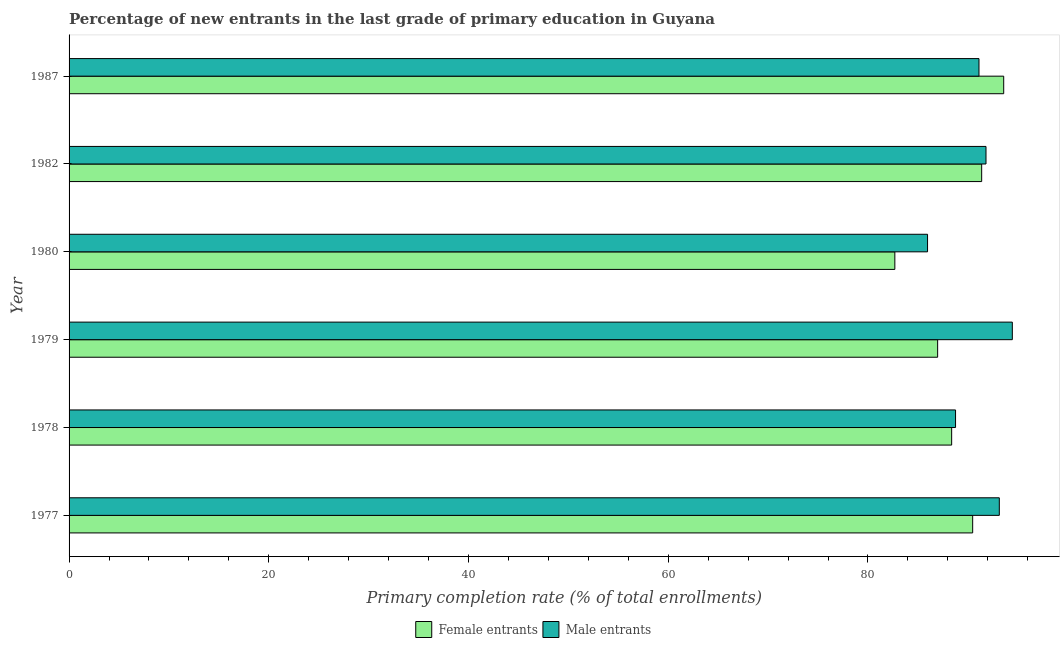How many groups of bars are there?
Offer a terse response. 6. How many bars are there on the 5th tick from the top?
Offer a terse response. 2. What is the primary completion rate of male entrants in 1979?
Your answer should be very brief. 94.45. Across all years, what is the maximum primary completion rate of female entrants?
Your answer should be very brief. 93.59. Across all years, what is the minimum primary completion rate of male entrants?
Give a very brief answer. 85.96. In which year was the primary completion rate of male entrants maximum?
Give a very brief answer. 1979. In which year was the primary completion rate of male entrants minimum?
Make the answer very short. 1980. What is the total primary completion rate of male entrants in the graph?
Offer a very short reply. 545.27. What is the difference between the primary completion rate of male entrants in 1977 and that in 1982?
Give a very brief answer. 1.33. What is the difference between the primary completion rate of female entrants in 1978 and the primary completion rate of male entrants in 1979?
Your response must be concise. -6.08. What is the average primary completion rate of male entrants per year?
Ensure brevity in your answer.  90.88. In the year 1980, what is the difference between the primary completion rate of female entrants and primary completion rate of male entrants?
Your answer should be very brief. -3.27. Is the primary completion rate of female entrants in 1978 less than that in 1987?
Offer a terse response. Yes. Is the difference between the primary completion rate of female entrants in 1980 and 1987 greater than the difference between the primary completion rate of male entrants in 1980 and 1987?
Keep it short and to the point. No. What is the difference between the highest and the second highest primary completion rate of female entrants?
Your answer should be compact. 2.21. What is the difference between the highest and the lowest primary completion rate of male entrants?
Ensure brevity in your answer.  8.49. In how many years, is the primary completion rate of female entrants greater than the average primary completion rate of female entrants taken over all years?
Make the answer very short. 3. What does the 1st bar from the top in 1987 represents?
Ensure brevity in your answer.  Male entrants. What does the 2nd bar from the bottom in 1982 represents?
Make the answer very short. Male entrants. How many bars are there?
Make the answer very short. 12. What is the difference between two consecutive major ticks on the X-axis?
Your answer should be very brief. 20. Are the values on the major ticks of X-axis written in scientific E-notation?
Provide a short and direct response. No. Does the graph contain grids?
Ensure brevity in your answer.  No. Where does the legend appear in the graph?
Give a very brief answer. Bottom center. What is the title of the graph?
Offer a very short reply. Percentage of new entrants in the last grade of primary education in Guyana. Does "Resident workers" appear as one of the legend labels in the graph?
Your response must be concise. No. What is the label or title of the X-axis?
Provide a short and direct response. Primary completion rate (% of total enrollments). What is the label or title of the Y-axis?
Ensure brevity in your answer.  Year. What is the Primary completion rate (% of total enrollments) in Female entrants in 1977?
Offer a terse response. 90.48. What is the Primary completion rate (% of total enrollments) in Male entrants in 1977?
Provide a short and direct response. 93.15. What is the Primary completion rate (% of total enrollments) in Female entrants in 1978?
Ensure brevity in your answer.  88.38. What is the Primary completion rate (% of total enrollments) in Male entrants in 1978?
Offer a terse response. 88.77. What is the Primary completion rate (% of total enrollments) in Female entrants in 1979?
Offer a terse response. 86.98. What is the Primary completion rate (% of total enrollments) of Male entrants in 1979?
Provide a short and direct response. 94.45. What is the Primary completion rate (% of total enrollments) of Female entrants in 1980?
Your answer should be compact. 82.69. What is the Primary completion rate (% of total enrollments) of Male entrants in 1980?
Make the answer very short. 85.96. What is the Primary completion rate (% of total enrollments) in Female entrants in 1982?
Your response must be concise. 91.38. What is the Primary completion rate (% of total enrollments) in Male entrants in 1982?
Offer a terse response. 91.82. What is the Primary completion rate (% of total enrollments) in Female entrants in 1987?
Ensure brevity in your answer.  93.59. What is the Primary completion rate (% of total enrollments) of Male entrants in 1987?
Provide a succinct answer. 91.12. Across all years, what is the maximum Primary completion rate (% of total enrollments) of Female entrants?
Provide a short and direct response. 93.59. Across all years, what is the maximum Primary completion rate (% of total enrollments) of Male entrants?
Provide a short and direct response. 94.45. Across all years, what is the minimum Primary completion rate (% of total enrollments) of Female entrants?
Provide a short and direct response. 82.69. Across all years, what is the minimum Primary completion rate (% of total enrollments) in Male entrants?
Your answer should be compact. 85.96. What is the total Primary completion rate (% of total enrollments) of Female entrants in the graph?
Provide a short and direct response. 533.5. What is the total Primary completion rate (% of total enrollments) of Male entrants in the graph?
Provide a short and direct response. 545.27. What is the difference between the Primary completion rate (% of total enrollments) in Female entrants in 1977 and that in 1978?
Your answer should be very brief. 2.1. What is the difference between the Primary completion rate (% of total enrollments) of Male entrants in 1977 and that in 1978?
Give a very brief answer. 4.38. What is the difference between the Primary completion rate (% of total enrollments) of Female entrants in 1977 and that in 1979?
Provide a succinct answer. 3.51. What is the difference between the Primary completion rate (% of total enrollments) of Male entrants in 1977 and that in 1979?
Provide a short and direct response. -1.3. What is the difference between the Primary completion rate (% of total enrollments) in Female entrants in 1977 and that in 1980?
Your answer should be compact. 7.79. What is the difference between the Primary completion rate (% of total enrollments) in Male entrants in 1977 and that in 1980?
Your answer should be very brief. 7.19. What is the difference between the Primary completion rate (% of total enrollments) of Female entrants in 1977 and that in 1982?
Your response must be concise. -0.9. What is the difference between the Primary completion rate (% of total enrollments) of Male entrants in 1977 and that in 1982?
Offer a terse response. 1.33. What is the difference between the Primary completion rate (% of total enrollments) of Female entrants in 1977 and that in 1987?
Offer a very short reply. -3.11. What is the difference between the Primary completion rate (% of total enrollments) of Male entrants in 1977 and that in 1987?
Your response must be concise. 2.03. What is the difference between the Primary completion rate (% of total enrollments) in Female entrants in 1978 and that in 1979?
Offer a very short reply. 1.4. What is the difference between the Primary completion rate (% of total enrollments) in Male entrants in 1978 and that in 1979?
Offer a very short reply. -5.69. What is the difference between the Primary completion rate (% of total enrollments) of Female entrants in 1978 and that in 1980?
Provide a short and direct response. 5.69. What is the difference between the Primary completion rate (% of total enrollments) in Male entrants in 1978 and that in 1980?
Make the answer very short. 2.8. What is the difference between the Primary completion rate (% of total enrollments) in Female entrants in 1978 and that in 1982?
Ensure brevity in your answer.  -3.01. What is the difference between the Primary completion rate (% of total enrollments) of Male entrants in 1978 and that in 1982?
Your answer should be very brief. -3.05. What is the difference between the Primary completion rate (% of total enrollments) of Female entrants in 1978 and that in 1987?
Provide a succinct answer. -5.21. What is the difference between the Primary completion rate (% of total enrollments) of Male entrants in 1978 and that in 1987?
Offer a terse response. -2.35. What is the difference between the Primary completion rate (% of total enrollments) of Female entrants in 1979 and that in 1980?
Give a very brief answer. 4.29. What is the difference between the Primary completion rate (% of total enrollments) in Male entrants in 1979 and that in 1980?
Provide a succinct answer. 8.49. What is the difference between the Primary completion rate (% of total enrollments) of Female entrants in 1979 and that in 1982?
Provide a short and direct response. -4.41. What is the difference between the Primary completion rate (% of total enrollments) in Male entrants in 1979 and that in 1982?
Make the answer very short. 2.64. What is the difference between the Primary completion rate (% of total enrollments) in Female entrants in 1979 and that in 1987?
Offer a terse response. -6.61. What is the difference between the Primary completion rate (% of total enrollments) in Male entrants in 1979 and that in 1987?
Offer a terse response. 3.34. What is the difference between the Primary completion rate (% of total enrollments) in Female entrants in 1980 and that in 1982?
Your response must be concise. -8.69. What is the difference between the Primary completion rate (% of total enrollments) of Male entrants in 1980 and that in 1982?
Make the answer very short. -5.85. What is the difference between the Primary completion rate (% of total enrollments) of Female entrants in 1980 and that in 1987?
Give a very brief answer. -10.9. What is the difference between the Primary completion rate (% of total enrollments) in Male entrants in 1980 and that in 1987?
Your response must be concise. -5.15. What is the difference between the Primary completion rate (% of total enrollments) of Female entrants in 1982 and that in 1987?
Keep it short and to the point. -2.21. What is the difference between the Primary completion rate (% of total enrollments) of Male entrants in 1982 and that in 1987?
Offer a terse response. 0.7. What is the difference between the Primary completion rate (% of total enrollments) of Female entrants in 1977 and the Primary completion rate (% of total enrollments) of Male entrants in 1978?
Your answer should be compact. 1.72. What is the difference between the Primary completion rate (% of total enrollments) of Female entrants in 1977 and the Primary completion rate (% of total enrollments) of Male entrants in 1979?
Provide a short and direct response. -3.97. What is the difference between the Primary completion rate (% of total enrollments) in Female entrants in 1977 and the Primary completion rate (% of total enrollments) in Male entrants in 1980?
Your response must be concise. 4.52. What is the difference between the Primary completion rate (% of total enrollments) of Female entrants in 1977 and the Primary completion rate (% of total enrollments) of Male entrants in 1982?
Make the answer very short. -1.33. What is the difference between the Primary completion rate (% of total enrollments) in Female entrants in 1977 and the Primary completion rate (% of total enrollments) in Male entrants in 1987?
Your answer should be very brief. -0.63. What is the difference between the Primary completion rate (% of total enrollments) of Female entrants in 1978 and the Primary completion rate (% of total enrollments) of Male entrants in 1979?
Your response must be concise. -6.08. What is the difference between the Primary completion rate (% of total enrollments) in Female entrants in 1978 and the Primary completion rate (% of total enrollments) in Male entrants in 1980?
Offer a very short reply. 2.41. What is the difference between the Primary completion rate (% of total enrollments) of Female entrants in 1978 and the Primary completion rate (% of total enrollments) of Male entrants in 1982?
Give a very brief answer. -3.44. What is the difference between the Primary completion rate (% of total enrollments) in Female entrants in 1978 and the Primary completion rate (% of total enrollments) in Male entrants in 1987?
Keep it short and to the point. -2.74. What is the difference between the Primary completion rate (% of total enrollments) in Female entrants in 1979 and the Primary completion rate (% of total enrollments) in Male entrants in 1980?
Your answer should be compact. 1.01. What is the difference between the Primary completion rate (% of total enrollments) of Female entrants in 1979 and the Primary completion rate (% of total enrollments) of Male entrants in 1982?
Ensure brevity in your answer.  -4.84. What is the difference between the Primary completion rate (% of total enrollments) in Female entrants in 1979 and the Primary completion rate (% of total enrollments) in Male entrants in 1987?
Keep it short and to the point. -4.14. What is the difference between the Primary completion rate (% of total enrollments) of Female entrants in 1980 and the Primary completion rate (% of total enrollments) of Male entrants in 1982?
Offer a very short reply. -9.13. What is the difference between the Primary completion rate (% of total enrollments) of Female entrants in 1980 and the Primary completion rate (% of total enrollments) of Male entrants in 1987?
Your answer should be very brief. -8.43. What is the difference between the Primary completion rate (% of total enrollments) in Female entrants in 1982 and the Primary completion rate (% of total enrollments) in Male entrants in 1987?
Make the answer very short. 0.27. What is the average Primary completion rate (% of total enrollments) in Female entrants per year?
Make the answer very short. 88.92. What is the average Primary completion rate (% of total enrollments) in Male entrants per year?
Your answer should be very brief. 90.88. In the year 1977, what is the difference between the Primary completion rate (% of total enrollments) in Female entrants and Primary completion rate (% of total enrollments) in Male entrants?
Provide a short and direct response. -2.67. In the year 1978, what is the difference between the Primary completion rate (% of total enrollments) in Female entrants and Primary completion rate (% of total enrollments) in Male entrants?
Provide a succinct answer. -0.39. In the year 1979, what is the difference between the Primary completion rate (% of total enrollments) of Female entrants and Primary completion rate (% of total enrollments) of Male entrants?
Your response must be concise. -7.48. In the year 1980, what is the difference between the Primary completion rate (% of total enrollments) of Female entrants and Primary completion rate (% of total enrollments) of Male entrants?
Ensure brevity in your answer.  -3.27. In the year 1982, what is the difference between the Primary completion rate (% of total enrollments) of Female entrants and Primary completion rate (% of total enrollments) of Male entrants?
Your answer should be very brief. -0.43. In the year 1987, what is the difference between the Primary completion rate (% of total enrollments) of Female entrants and Primary completion rate (% of total enrollments) of Male entrants?
Your answer should be very brief. 2.47. What is the ratio of the Primary completion rate (% of total enrollments) in Female entrants in 1977 to that in 1978?
Give a very brief answer. 1.02. What is the ratio of the Primary completion rate (% of total enrollments) of Male entrants in 1977 to that in 1978?
Offer a very short reply. 1.05. What is the ratio of the Primary completion rate (% of total enrollments) of Female entrants in 1977 to that in 1979?
Your answer should be very brief. 1.04. What is the ratio of the Primary completion rate (% of total enrollments) in Male entrants in 1977 to that in 1979?
Offer a terse response. 0.99. What is the ratio of the Primary completion rate (% of total enrollments) in Female entrants in 1977 to that in 1980?
Provide a short and direct response. 1.09. What is the ratio of the Primary completion rate (% of total enrollments) in Male entrants in 1977 to that in 1980?
Your answer should be compact. 1.08. What is the ratio of the Primary completion rate (% of total enrollments) in Male entrants in 1977 to that in 1982?
Ensure brevity in your answer.  1.01. What is the ratio of the Primary completion rate (% of total enrollments) of Female entrants in 1977 to that in 1987?
Your answer should be very brief. 0.97. What is the ratio of the Primary completion rate (% of total enrollments) in Male entrants in 1977 to that in 1987?
Your response must be concise. 1.02. What is the ratio of the Primary completion rate (% of total enrollments) of Female entrants in 1978 to that in 1979?
Give a very brief answer. 1.02. What is the ratio of the Primary completion rate (% of total enrollments) of Male entrants in 1978 to that in 1979?
Provide a succinct answer. 0.94. What is the ratio of the Primary completion rate (% of total enrollments) in Female entrants in 1978 to that in 1980?
Provide a short and direct response. 1.07. What is the ratio of the Primary completion rate (% of total enrollments) of Male entrants in 1978 to that in 1980?
Offer a very short reply. 1.03. What is the ratio of the Primary completion rate (% of total enrollments) of Female entrants in 1978 to that in 1982?
Make the answer very short. 0.97. What is the ratio of the Primary completion rate (% of total enrollments) in Male entrants in 1978 to that in 1982?
Offer a terse response. 0.97. What is the ratio of the Primary completion rate (% of total enrollments) of Female entrants in 1978 to that in 1987?
Ensure brevity in your answer.  0.94. What is the ratio of the Primary completion rate (% of total enrollments) of Male entrants in 1978 to that in 1987?
Keep it short and to the point. 0.97. What is the ratio of the Primary completion rate (% of total enrollments) of Female entrants in 1979 to that in 1980?
Your answer should be compact. 1.05. What is the ratio of the Primary completion rate (% of total enrollments) of Male entrants in 1979 to that in 1980?
Keep it short and to the point. 1.1. What is the ratio of the Primary completion rate (% of total enrollments) in Female entrants in 1979 to that in 1982?
Provide a short and direct response. 0.95. What is the ratio of the Primary completion rate (% of total enrollments) in Male entrants in 1979 to that in 1982?
Provide a short and direct response. 1.03. What is the ratio of the Primary completion rate (% of total enrollments) of Female entrants in 1979 to that in 1987?
Provide a succinct answer. 0.93. What is the ratio of the Primary completion rate (% of total enrollments) of Male entrants in 1979 to that in 1987?
Offer a terse response. 1.04. What is the ratio of the Primary completion rate (% of total enrollments) of Female entrants in 1980 to that in 1982?
Your response must be concise. 0.9. What is the ratio of the Primary completion rate (% of total enrollments) in Male entrants in 1980 to that in 1982?
Give a very brief answer. 0.94. What is the ratio of the Primary completion rate (% of total enrollments) of Female entrants in 1980 to that in 1987?
Your answer should be very brief. 0.88. What is the ratio of the Primary completion rate (% of total enrollments) of Male entrants in 1980 to that in 1987?
Ensure brevity in your answer.  0.94. What is the ratio of the Primary completion rate (% of total enrollments) in Female entrants in 1982 to that in 1987?
Offer a very short reply. 0.98. What is the ratio of the Primary completion rate (% of total enrollments) of Male entrants in 1982 to that in 1987?
Make the answer very short. 1.01. What is the difference between the highest and the second highest Primary completion rate (% of total enrollments) of Female entrants?
Ensure brevity in your answer.  2.21. What is the difference between the highest and the second highest Primary completion rate (% of total enrollments) of Male entrants?
Provide a short and direct response. 1.3. What is the difference between the highest and the lowest Primary completion rate (% of total enrollments) in Female entrants?
Make the answer very short. 10.9. What is the difference between the highest and the lowest Primary completion rate (% of total enrollments) in Male entrants?
Give a very brief answer. 8.49. 